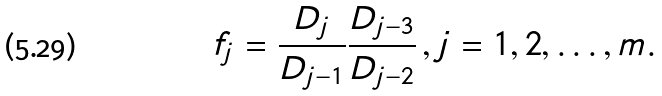<formula> <loc_0><loc_0><loc_500><loc_500>f _ { j } = \frac { D _ { j } } { D _ { j - 1 } } \frac { D _ { j - 3 } } { D _ { j - 2 } } \, , j = 1 , 2 , \dots , m .</formula> 